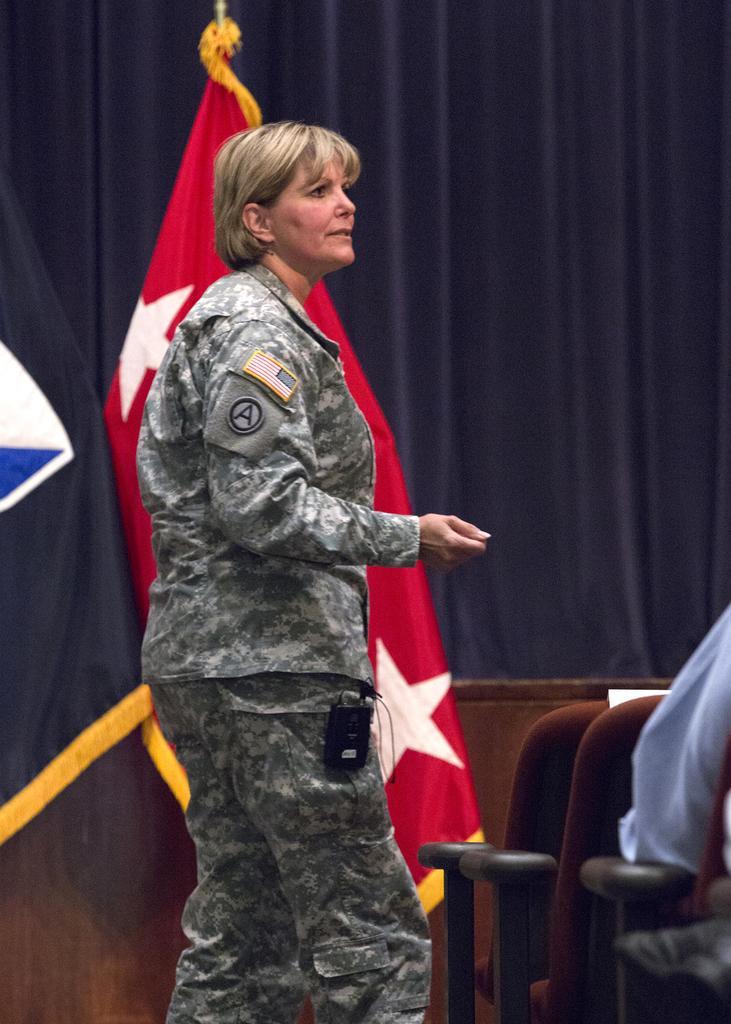How would you summarize this image in a sentence or two? In this image we can see a woman wearing uniform is standing here. Here we can see chairs and a person sitting on it. In the background, we can see flags, wooden wall and the dark blue color curtains. 